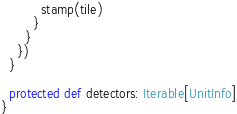<code> <loc_0><loc_0><loc_500><loc_500><_Scala_>          stamp(tile)
        }
      }
    })
  }
  
  protected def detectors: Iterable[UnitInfo]
}</code> 